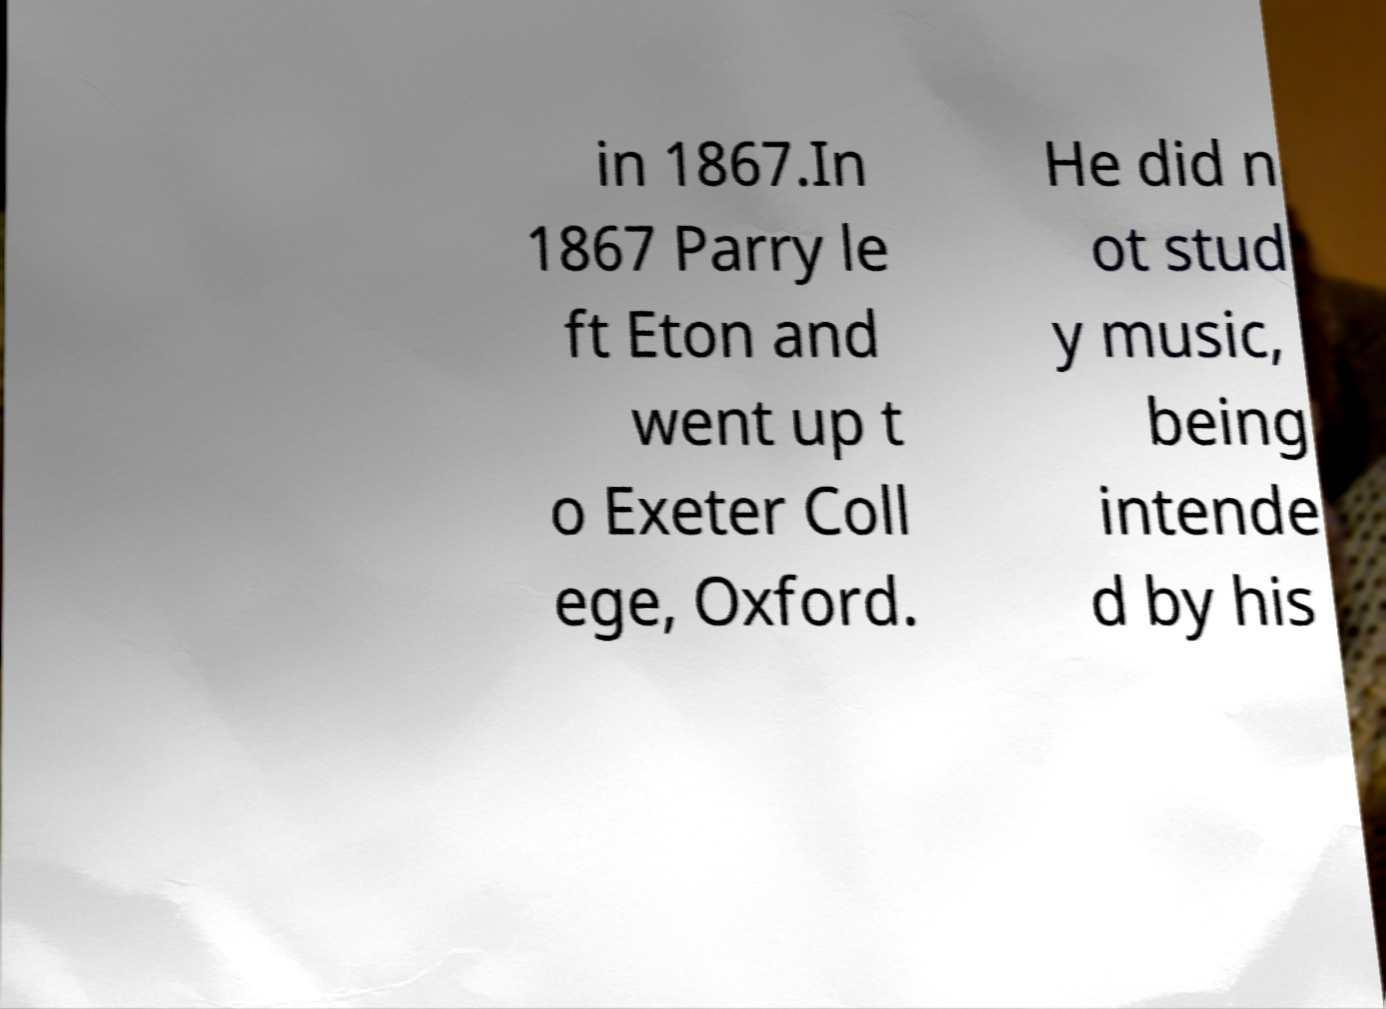Could you assist in decoding the text presented in this image and type it out clearly? in 1867.In 1867 Parry le ft Eton and went up t o Exeter Coll ege, Oxford. He did n ot stud y music, being intende d by his 